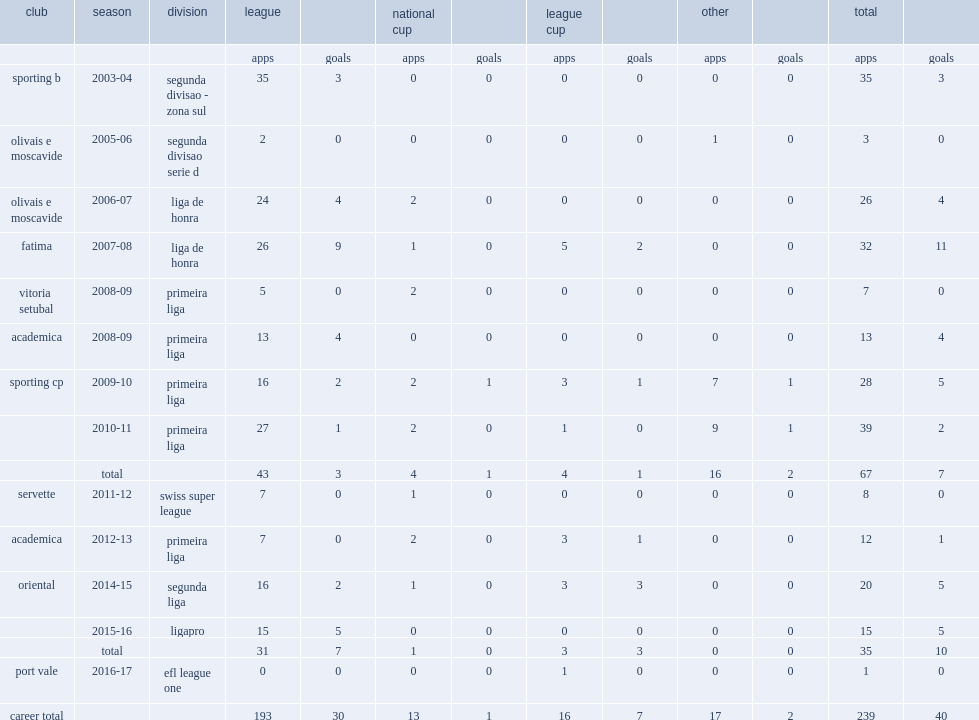How many matches did carlos saleiro play whn he spent the 2003-04 season with sporting b? 35.0. 